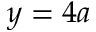<formula> <loc_0><loc_0><loc_500><loc_500>y = 4 a</formula> 